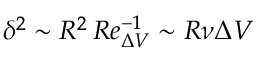Convert formula to latex. <formula><loc_0><loc_0><loc_500><loc_500>\delta ^ { 2 } \sim R ^ { 2 } \, R e _ { \Delta V } ^ { - 1 } \sim R \nu \Delta V</formula> 